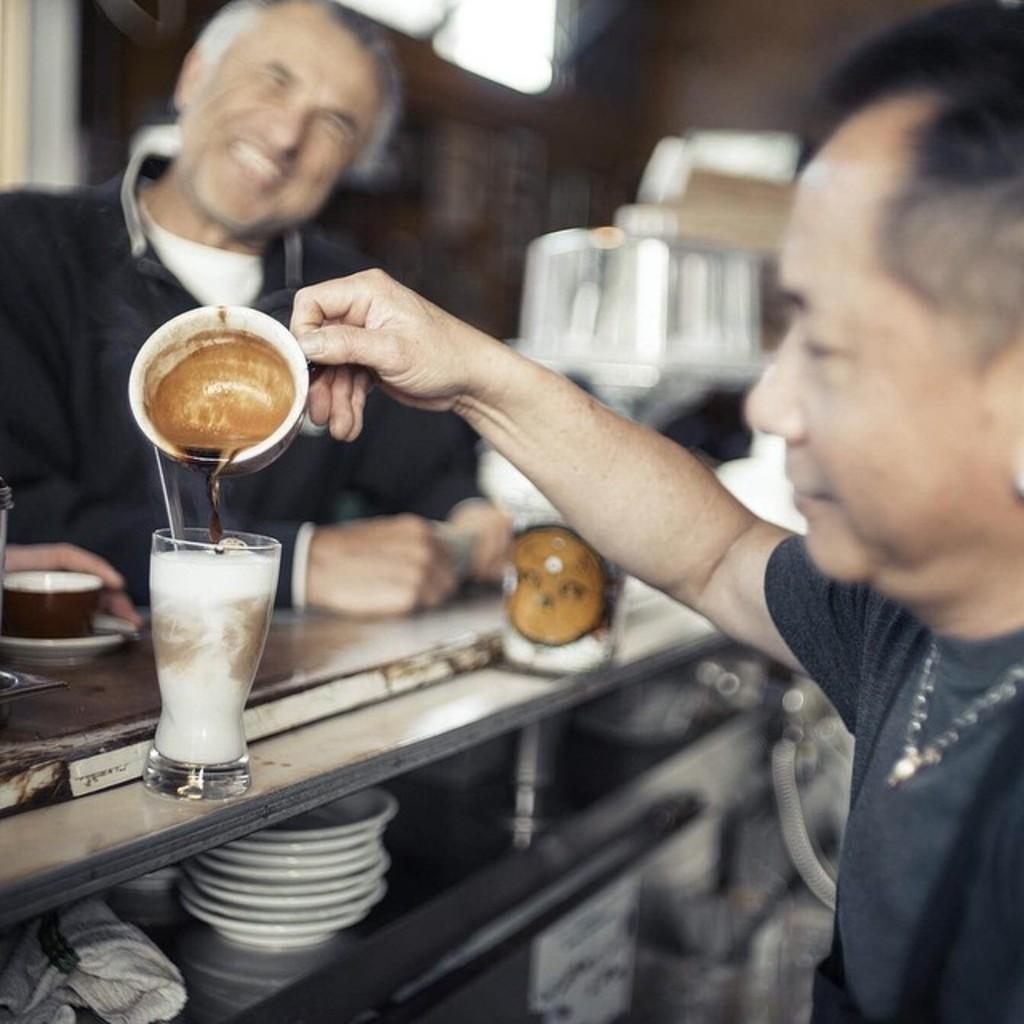How many people are in the image? There are two men in the image. What are the men wearing? The men are wearing clothes. What is the facial expression of the men? The men are smiling. What type of accessory can be seen on one of the men? There is a neck chain visible in the image. What type of objects can be seen in the image related to beverages? There is a glass, a tea cup, and a saucer in the image. How would you describe the background of the image? The background of the image is blurred. What type of fog can be seen in the image? There is no fog present in the image; the background is blurred, but it is not due to fog. 